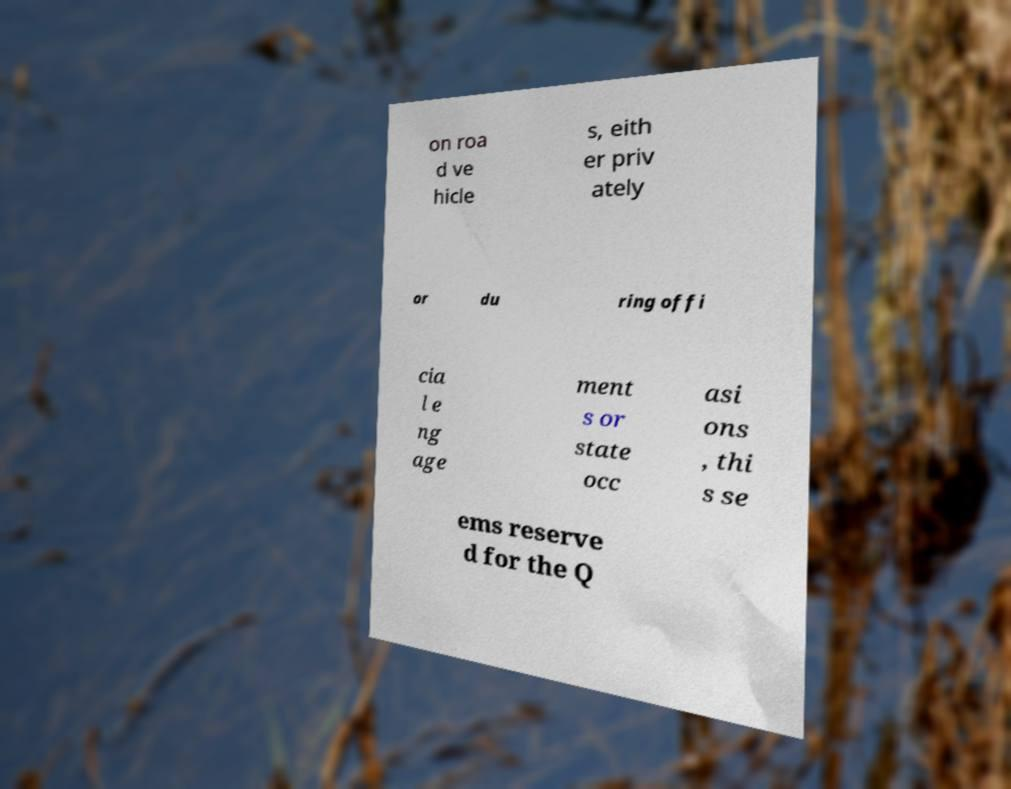What messages or text are displayed in this image? I need them in a readable, typed format. on roa d ve hicle s, eith er priv ately or du ring offi cia l e ng age ment s or state occ asi ons , thi s se ems reserve d for the Q 